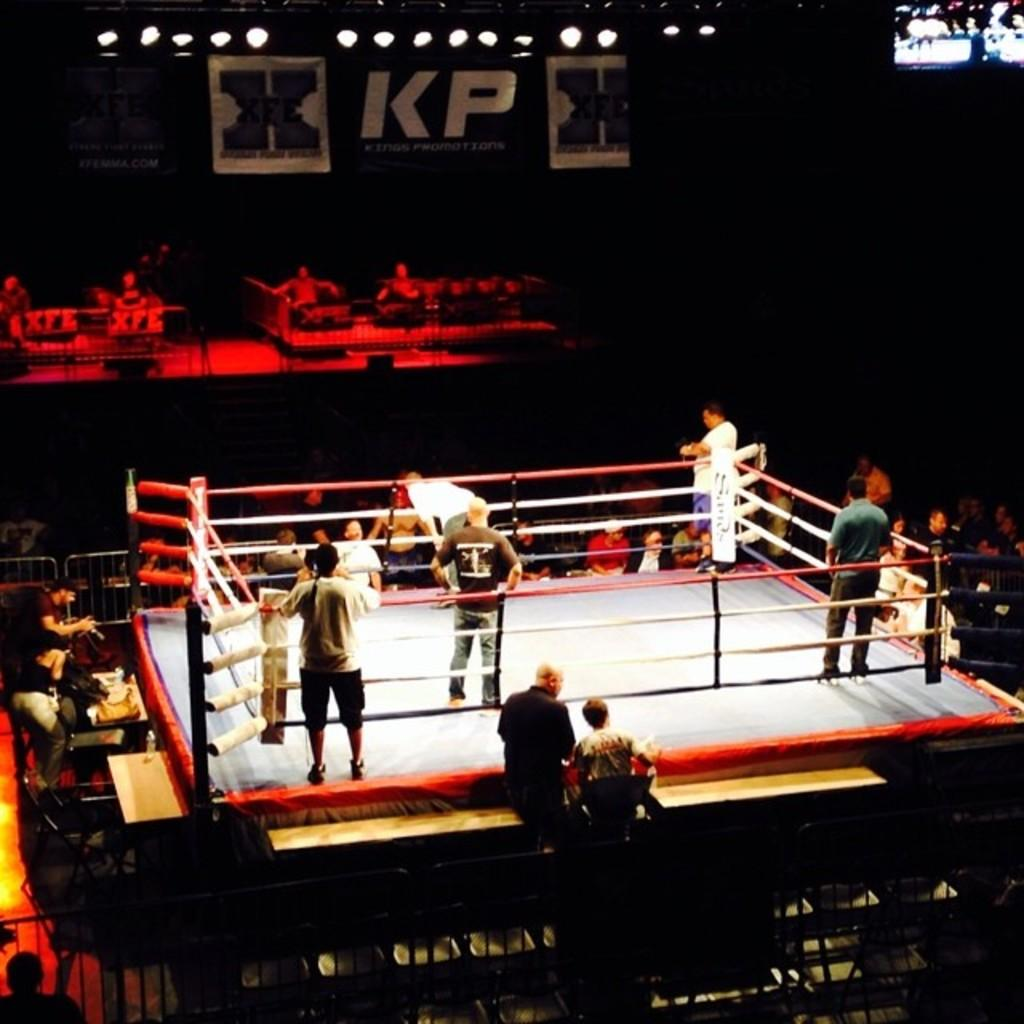<image>
Offer a succinct explanation of the picture presented. Wrestlers stand around in a KP wrestling ring 